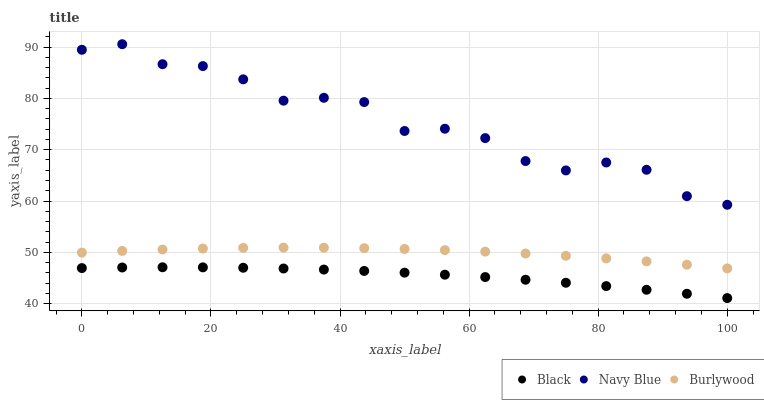Does Black have the minimum area under the curve?
Answer yes or no. Yes. Does Navy Blue have the maximum area under the curve?
Answer yes or no. Yes. Does Navy Blue have the minimum area under the curve?
Answer yes or no. No. Does Black have the maximum area under the curve?
Answer yes or no. No. Is Black the smoothest?
Answer yes or no. Yes. Is Navy Blue the roughest?
Answer yes or no. Yes. Is Navy Blue the smoothest?
Answer yes or no. No. Is Black the roughest?
Answer yes or no. No. Does Black have the lowest value?
Answer yes or no. Yes. Does Navy Blue have the lowest value?
Answer yes or no. No. Does Navy Blue have the highest value?
Answer yes or no. Yes. Does Black have the highest value?
Answer yes or no. No. Is Black less than Navy Blue?
Answer yes or no. Yes. Is Navy Blue greater than Burlywood?
Answer yes or no. Yes. Does Black intersect Navy Blue?
Answer yes or no. No. 